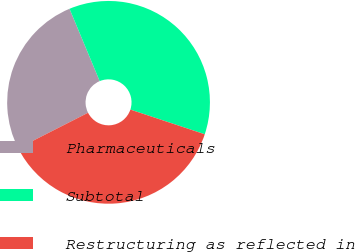Convert chart. <chart><loc_0><loc_0><loc_500><loc_500><pie_chart><fcel>Pharmaceuticals<fcel>Subtotal<fcel>Restructuring as reflected in<nl><fcel>26.2%<fcel>36.39%<fcel>37.41%<nl></chart> 